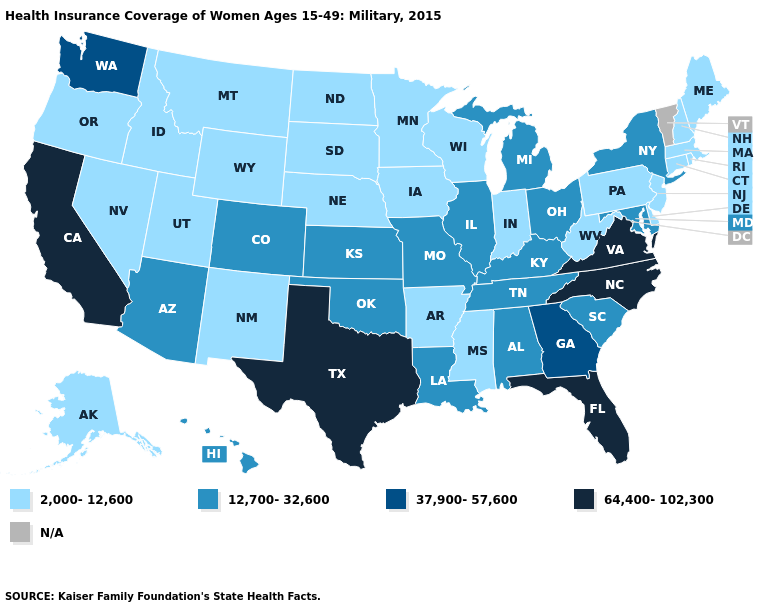What is the highest value in the USA?
Give a very brief answer. 64,400-102,300. Among the states that border Maine , which have the highest value?
Quick response, please. New Hampshire. What is the lowest value in the USA?
Give a very brief answer. 2,000-12,600. What is the value of Kansas?
Quick response, please. 12,700-32,600. How many symbols are there in the legend?
Answer briefly. 5. What is the value of Kansas?
Answer briefly. 12,700-32,600. Which states have the highest value in the USA?
Write a very short answer. California, Florida, North Carolina, Texas, Virginia. Name the states that have a value in the range 2,000-12,600?
Short answer required. Alaska, Arkansas, Connecticut, Delaware, Idaho, Indiana, Iowa, Maine, Massachusetts, Minnesota, Mississippi, Montana, Nebraska, Nevada, New Hampshire, New Jersey, New Mexico, North Dakota, Oregon, Pennsylvania, Rhode Island, South Dakota, Utah, West Virginia, Wisconsin, Wyoming. Name the states that have a value in the range N/A?
Be succinct. Vermont. Name the states that have a value in the range 37,900-57,600?
Short answer required. Georgia, Washington. Name the states that have a value in the range 64,400-102,300?
Give a very brief answer. California, Florida, North Carolina, Texas, Virginia. Name the states that have a value in the range N/A?
Be succinct. Vermont. Which states have the highest value in the USA?
Quick response, please. California, Florida, North Carolina, Texas, Virginia. What is the lowest value in the West?
Quick response, please. 2,000-12,600. 